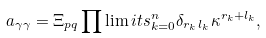<formula> <loc_0><loc_0><loc_500><loc_500>a _ { \gamma \gamma } = \Xi _ { p q } \prod \lim i t s _ { k = 0 } ^ { n } \delta _ { r _ { k \, } l _ { k } } \kappa ^ { r _ { k } + l _ { k } } ,</formula> 